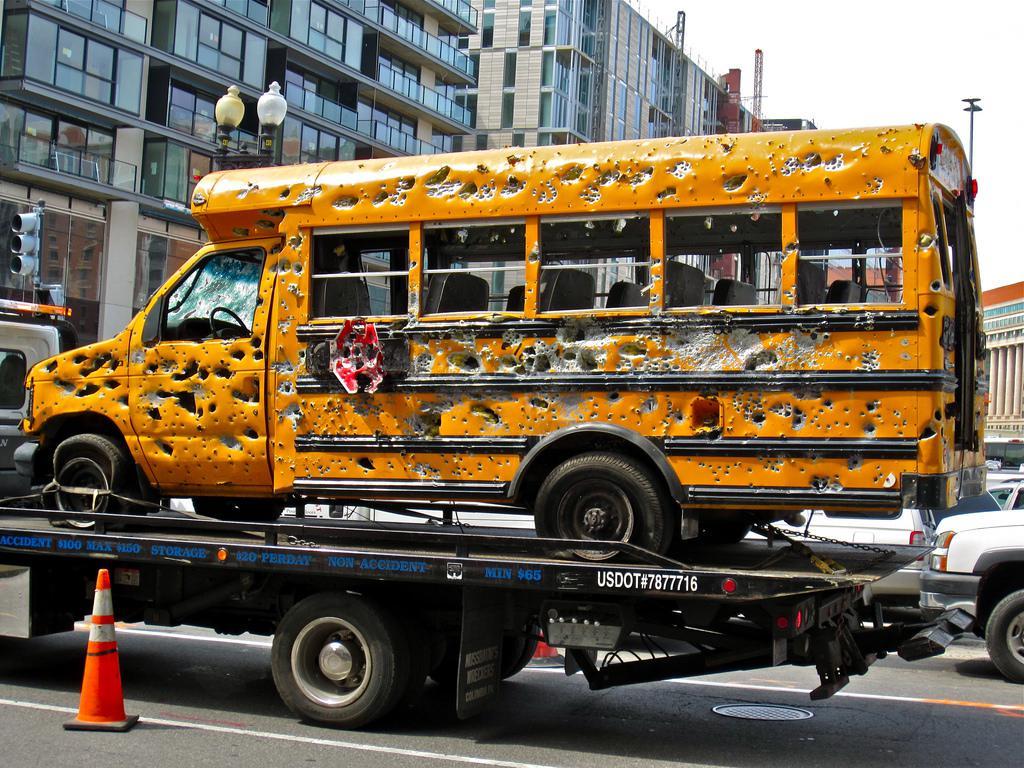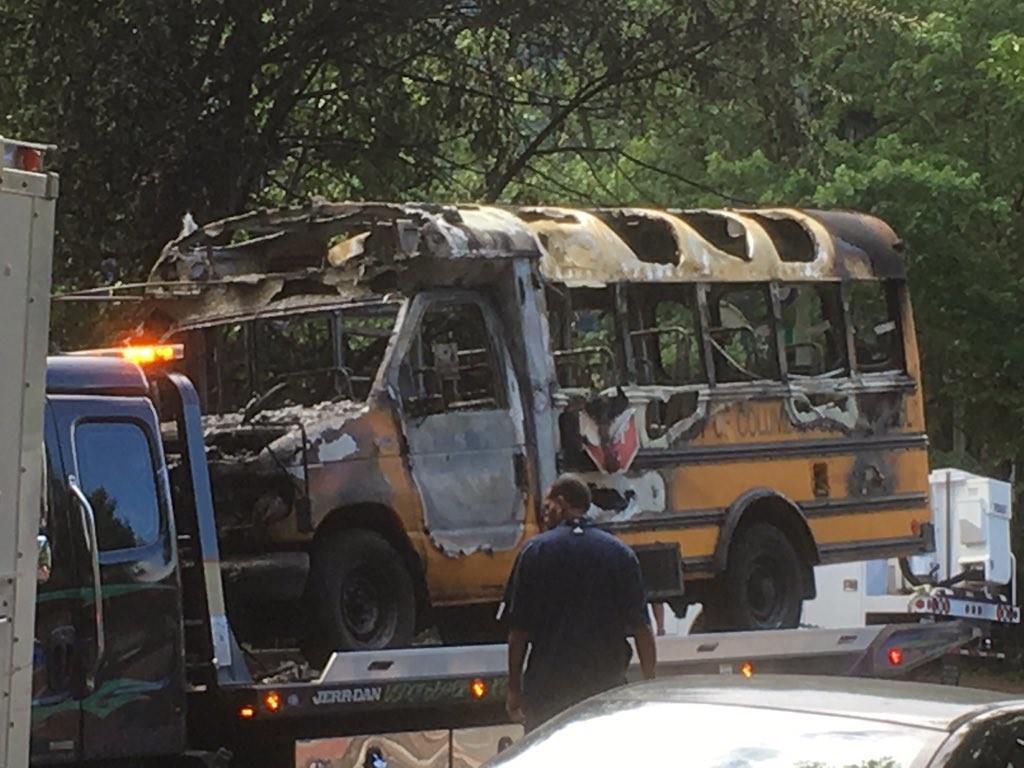The first image is the image on the left, the second image is the image on the right. Analyze the images presented: Is the assertion "The door of the bus in the image on the left has its door open." valid? Answer yes or no. No. The first image is the image on the left, the second image is the image on the right. Examine the images to the left and right. Is the description "There is no apparent damage to the bus in the image on the right." accurate? Answer yes or no. No. 